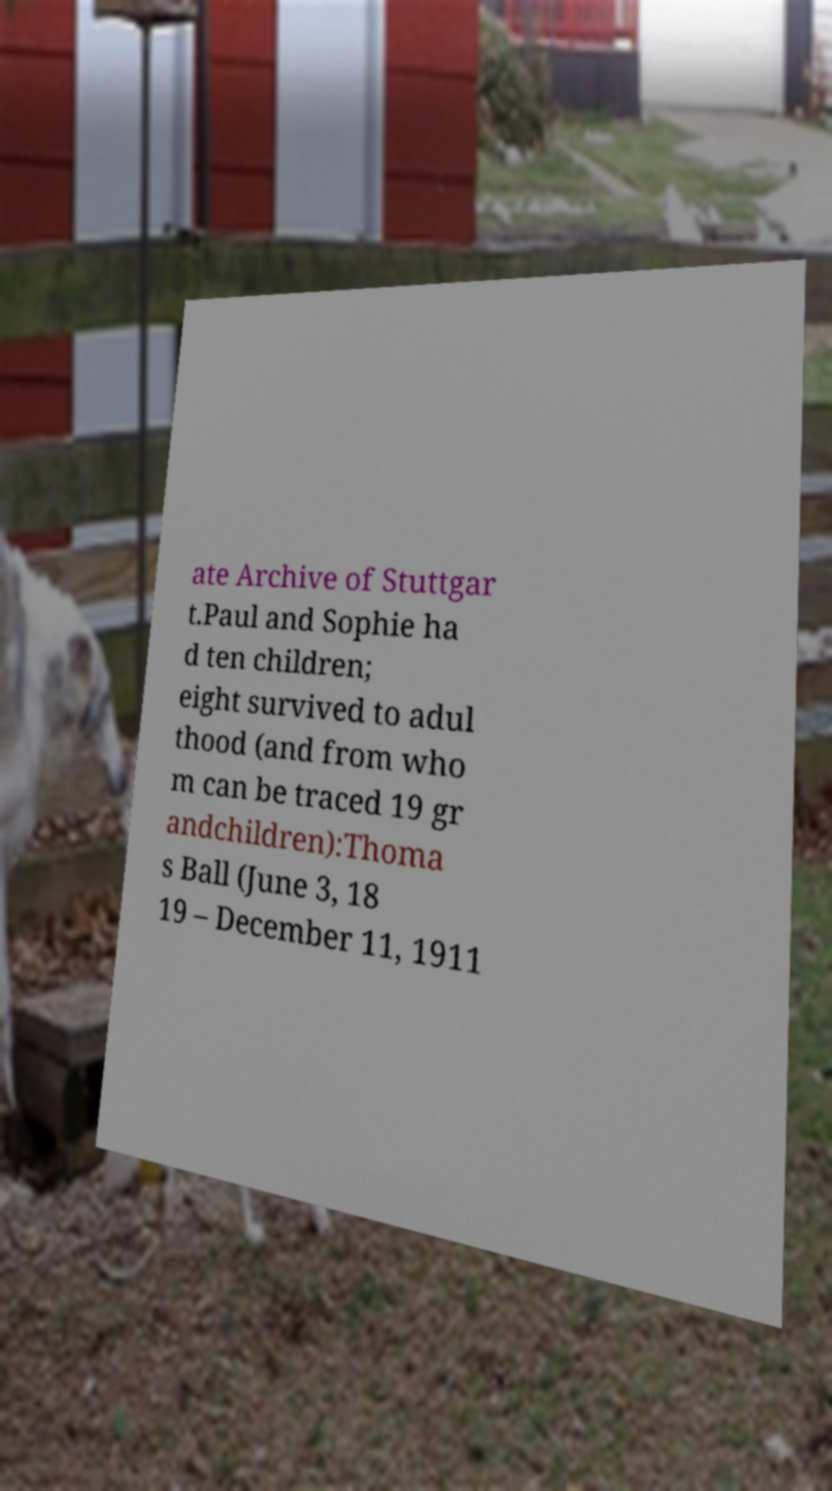Please identify and transcribe the text found in this image. ate Archive of Stuttgar t.Paul and Sophie ha d ten children; eight survived to adul thood (and from who m can be traced 19 gr andchildren):Thoma s Ball (June 3, 18 19 – December 11, 1911 